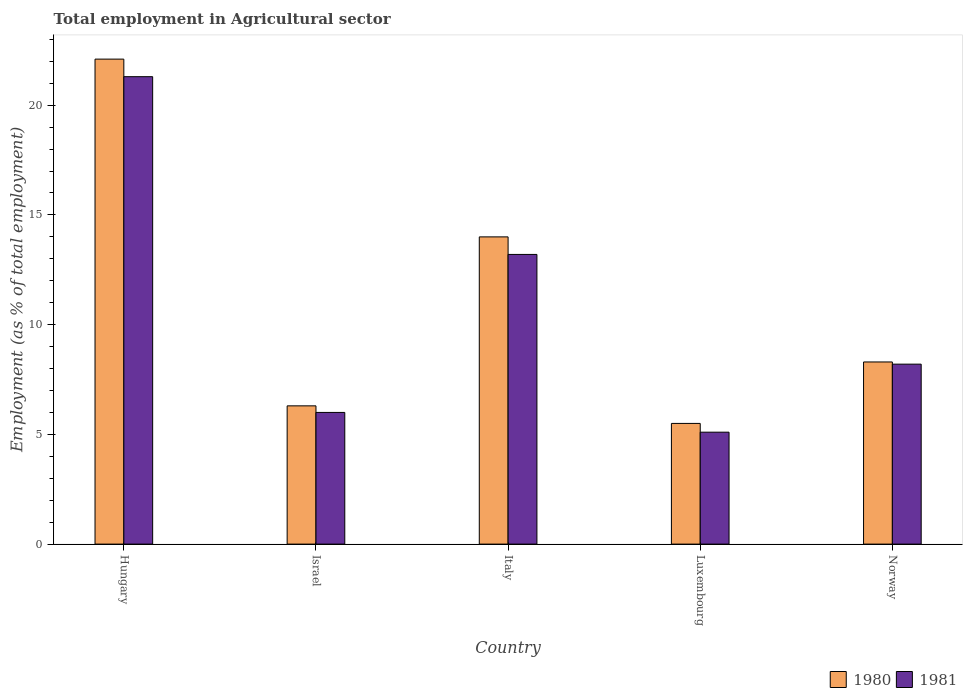How many different coloured bars are there?
Give a very brief answer. 2. How many groups of bars are there?
Offer a very short reply. 5. How many bars are there on the 3rd tick from the left?
Offer a very short reply. 2. How many bars are there on the 4th tick from the right?
Make the answer very short. 2. In how many cases, is the number of bars for a given country not equal to the number of legend labels?
Ensure brevity in your answer.  0. What is the employment in agricultural sector in 1980 in Israel?
Ensure brevity in your answer.  6.3. Across all countries, what is the maximum employment in agricultural sector in 1981?
Give a very brief answer. 21.3. Across all countries, what is the minimum employment in agricultural sector in 1980?
Provide a short and direct response. 5.5. In which country was the employment in agricultural sector in 1981 maximum?
Your answer should be compact. Hungary. In which country was the employment in agricultural sector in 1980 minimum?
Your answer should be very brief. Luxembourg. What is the total employment in agricultural sector in 1981 in the graph?
Your answer should be compact. 53.8. What is the difference between the employment in agricultural sector in 1980 in Hungary and that in Norway?
Offer a terse response. 13.8. What is the difference between the employment in agricultural sector in 1980 in Hungary and the employment in agricultural sector in 1981 in Norway?
Ensure brevity in your answer.  13.9. What is the average employment in agricultural sector in 1980 per country?
Ensure brevity in your answer.  11.24. What is the difference between the employment in agricultural sector of/in 1980 and employment in agricultural sector of/in 1981 in Hungary?
Provide a short and direct response. 0.8. In how many countries, is the employment in agricultural sector in 1981 greater than 12 %?
Your answer should be compact. 2. What is the ratio of the employment in agricultural sector in 1981 in Hungary to that in Italy?
Make the answer very short. 1.61. What is the difference between the highest and the second highest employment in agricultural sector in 1980?
Your response must be concise. -13.8. What is the difference between the highest and the lowest employment in agricultural sector in 1980?
Offer a very short reply. 16.6. What does the 2nd bar from the left in Israel represents?
Make the answer very short. 1981. What does the 2nd bar from the right in Luxembourg represents?
Keep it short and to the point. 1980. How many countries are there in the graph?
Provide a short and direct response. 5. What is the difference between two consecutive major ticks on the Y-axis?
Your answer should be very brief. 5. Are the values on the major ticks of Y-axis written in scientific E-notation?
Your answer should be compact. No. Does the graph contain any zero values?
Give a very brief answer. No. What is the title of the graph?
Ensure brevity in your answer.  Total employment in Agricultural sector. What is the label or title of the X-axis?
Your response must be concise. Country. What is the label or title of the Y-axis?
Give a very brief answer. Employment (as % of total employment). What is the Employment (as % of total employment) of 1980 in Hungary?
Ensure brevity in your answer.  22.1. What is the Employment (as % of total employment) of 1981 in Hungary?
Give a very brief answer. 21.3. What is the Employment (as % of total employment) of 1980 in Israel?
Your response must be concise. 6.3. What is the Employment (as % of total employment) in 1981 in Israel?
Keep it short and to the point. 6. What is the Employment (as % of total employment) of 1980 in Italy?
Offer a terse response. 14. What is the Employment (as % of total employment) in 1981 in Italy?
Your answer should be very brief. 13.2. What is the Employment (as % of total employment) of 1980 in Luxembourg?
Offer a very short reply. 5.5. What is the Employment (as % of total employment) in 1981 in Luxembourg?
Provide a short and direct response. 5.1. What is the Employment (as % of total employment) of 1980 in Norway?
Your response must be concise. 8.3. What is the Employment (as % of total employment) in 1981 in Norway?
Give a very brief answer. 8.2. Across all countries, what is the maximum Employment (as % of total employment) in 1980?
Your response must be concise. 22.1. Across all countries, what is the maximum Employment (as % of total employment) of 1981?
Provide a short and direct response. 21.3. Across all countries, what is the minimum Employment (as % of total employment) in 1981?
Give a very brief answer. 5.1. What is the total Employment (as % of total employment) of 1980 in the graph?
Keep it short and to the point. 56.2. What is the total Employment (as % of total employment) of 1981 in the graph?
Offer a very short reply. 53.8. What is the difference between the Employment (as % of total employment) of 1981 in Hungary and that in Israel?
Your answer should be very brief. 15.3. What is the difference between the Employment (as % of total employment) of 1980 in Hungary and that in Italy?
Your answer should be very brief. 8.1. What is the difference between the Employment (as % of total employment) of 1981 in Hungary and that in Luxembourg?
Your answer should be compact. 16.2. What is the difference between the Employment (as % of total employment) in 1980 in Israel and that in Italy?
Make the answer very short. -7.7. What is the difference between the Employment (as % of total employment) of 1981 in Israel and that in Italy?
Keep it short and to the point. -7.2. What is the difference between the Employment (as % of total employment) of 1980 in Israel and that in Luxembourg?
Your answer should be compact. 0.8. What is the difference between the Employment (as % of total employment) of 1980 in Italy and that in Luxembourg?
Your answer should be compact. 8.5. What is the difference between the Employment (as % of total employment) in 1980 in Hungary and the Employment (as % of total employment) in 1981 in Norway?
Make the answer very short. 13.9. What is the difference between the Employment (as % of total employment) in 1980 in Italy and the Employment (as % of total employment) in 1981 in Luxembourg?
Ensure brevity in your answer.  8.9. What is the difference between the Employment (as % of total employment) in 1980 in Luxembourg and the Employment (as % of total employment) in 1981 in Norway?
Ensure brevity in your answer.  -2.7. What is the average Employment (as % of total employment) in 1980 per country?
Provide a short and direct response. 11.24. What is the average Employment (as % of total employment) of 1981 per country?
Provide a succinct answer. 10.76. What is the difference between the Employment (as % of total employment) of 1980 and Employment (as % of total employment) of 1981 in Hungary?
Offer a very short reply. 0.8. What is the difference between the Employment (as % of total employment) of 1980 and Employment (as % of total employment) of 1981 in Israel?
Provide a short and direct response. 0.3. What is the difference between the Employment (as % of total employment) of 1980 and Employment (as % of total employment) of 1981 in Italy?
Your answer should be very brief. 0.8. What is the difference between the Employment (as % of total employment) of 1980 and Employment (as % of total employment) of 1981 in Norway?
Your response must be concise. 0.1. What is the ratio of the Employment (as % of total employment) of 1980 in Hungary to that in Israel?
Provide a short and direct response. 3.51. What is the ratio of the Employment (as % of total employment) in 1981 in Hungary to that in Israel?
Ensure brevity in your answer.  3.55. What is the ratio of the Employment (as % of total employment) of 1980 in Hungary to that in Italy?
Keep it short and to the point. 1.58. What is the ratio of the Employment (as % of total employment) of 1981 in Hungary to that in Italy?
Make the answer very short. 1.61. What is the ratio of the Employment (as % of total employment) in 1980 in Hungary to that in Luxembourg?
Ensure brevity in your answer.  4.02. What is the ratio of the Employment (as % of total employment) of 1981 in Hungary to that in Luxembourg?
Offer a terse response. 4.18. What is the ratio of the Employment (as % of total employment) of 1980 in Hungary to that in Norway?
Your answer should be compact. 2.66. What is the ratio of the Employment (as % of total employment) in 1981 in Hungary to that in Norway?
Ensure brevity in your answer.  2.6. What is the ratio of the Employment (as % of total employment) of 1980 in Israel to that in Italy?
Provide a succinct answer. 0.45. What is the ratio of the Employment (as % of total employment) in 1981 in Israel to that in Italy?
Your answer should be compact. 0.45. What is the ratio of the Employment (as % of total employment) of 1980 in Israel to that in Luxembourg?
Your answer should be very brief. 1.15. What is the ratio of the Employment (as % of total employment) in 1981 in Israel to that in Luxembourg?
Your answer should be very brief. 1.18. What is the ratio of the Employment (as % of total employment) in 1980 in Israel to that in Norway?
Make the answer very short. 0.76. What is the ratio of the Employment (as % of total employment) in 1981 in Israel to that in Norway?
Keep it short and to the point. 0.73. What is the ratio of the Employment (as % of total employment) of 1980 in Italy to that in Luxembourg?
Your response must be concise. 2.55. What is the ratio of the Employment (as % of total employment) of 1981 in Italy to that in Luxembourg?
Provide a short and direct response. 2.59. What is the ratio of the Employment (as % of total employment) of 1980 in Italy to that in Norway?
Your response must be concise. 1.69. What is the ratio of the Employment (as % of total employment) in 1981 in Italy to that in Norway?
Keep it short and to the point. 1.61. What is the ratio of the Employment (as % of total employment) of 1980 in Luxembourg to that in Norway?
Keep it short and to the point. 0.66. What is the ratio of the Employment (as % of total employment) in 1981 in Luxembourg to that in Norway?
Your response must be concise. 0.62. What is the difference between the highest and the second highest Employment (as % of total employment) in 1981?
Your response must be concise. 8.1. 